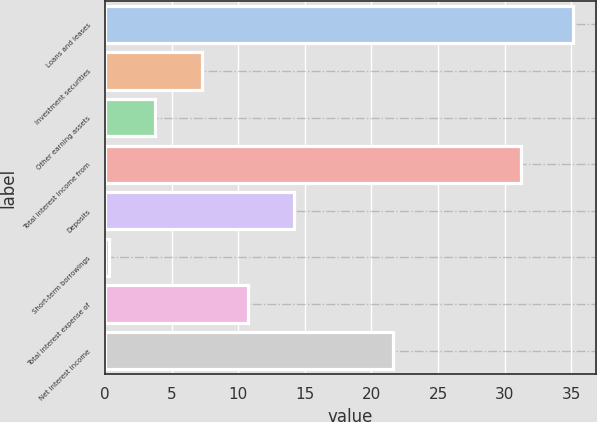<chart> <loc_0><loc_0><loc_500><loc_500><bar_chart><fcel>Loans and leases<fcel>Investment securities<fcel>Other earning assets<fcel>Total interest income from<fcel>Deposits<fcel>Short-term borrowings<fcel>Total interest expense of<fcel>Net interest income<nl><fcel>35.1<fcel>7.26<fcel>3.78<fcel>31.2<fcel>14.22<fcel>0.3<fcel>10.74<fcel>21.6<nl></chart> 